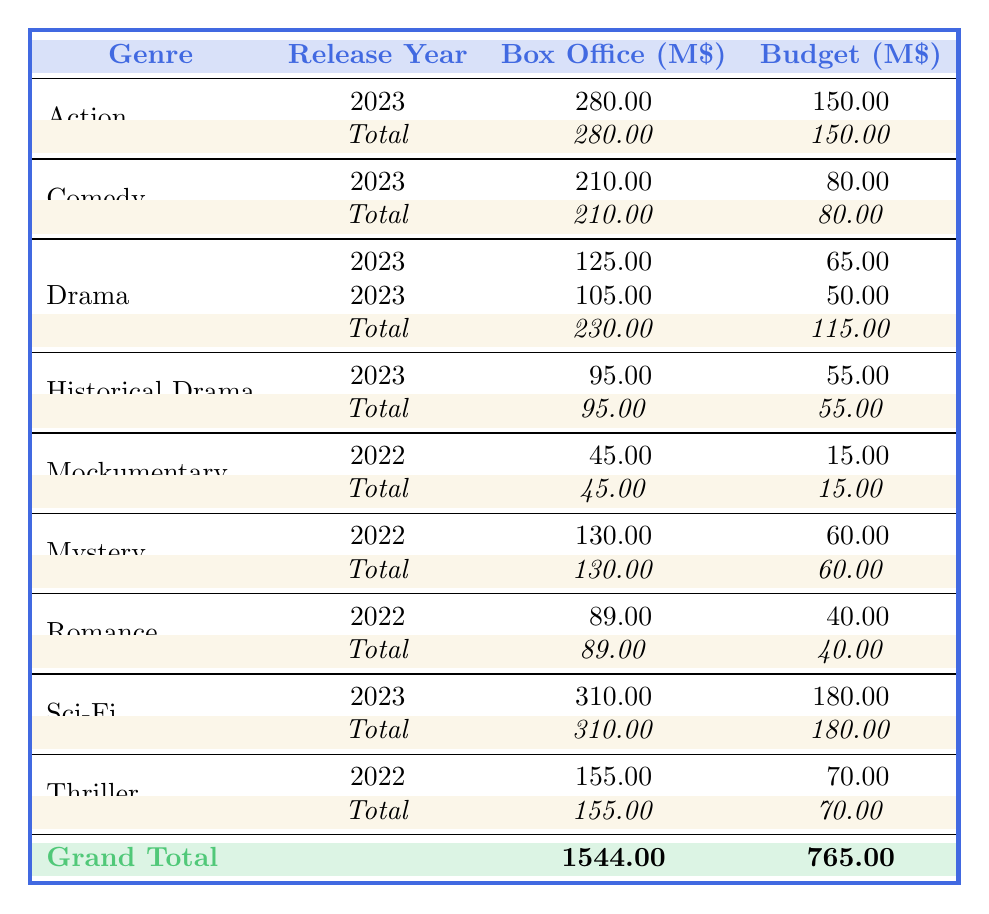What is the box office earnings of the movie "Galactic Diva"? The table lists "Galactic Diva" under the Sci-Fi genre for the year 2023 with box office earnings of 310 million dollars.
Answer: 310 million Which genre had the highest box office earnings in 2023? Looking at the table, Sci-Fi has the highest earnings at 310 million dollars compared to other genres in 2023.
Answer: Sci-Fi What is the total box office earnings for the Drama genre? The Drama genre includes two entries: "The Eccentric's Gambit" earning 125 million and "Chateau Marmont Confidential" earning 105 million. Thus, the total is 125 + 105 = 230 million.
Answer: 230 million Did the movie "Paparazzi Panic" have a higher production budget than "Midnight in Cannes"? The production budget for "Paparazzi Panic" is 80 million while "Midnight in Cannes" has a budget of 40 million. Therefore, "Paparazzi Panic" indeed has a higher budget.
Answer: Yes What is the average box office earnings for movies released in 2022? The table shows box office earnings for three movies released in 2022: "Midnight in Cannes" (89 million), "The Method Actor's Revenge" (155 million), and "The Last Take" (130 million). Summing these gives 89 + 155 + 130 = 374 million. Dividing this sum by 3 movies gives an average of 374 / 3 = 124.67 million.
Answer: 124.67 million Which genre had the least box office earnings in 2022? In the table, the genres with earnings in 2022 are Thriller (155 million), Romance (89 million), Mystery (130 million), and Mockumentary (45 million). The Mockumentary genre has the least earnings of 45 million.
Answer: Mockumentary What are the total production budgets for all movies released in 2023? The production budgets for 2023 movies are: "The Eccentric's Gambit" (65 million), "Galactic Diva" (180 million), "Paparazzi Panic" (80 million), "Red Carpet Rampage" (150 million), and "Oscar Bait" (55 million). Adding these gives 65 + 180 + 80 + 150 + 55 = 530 million.
Answer: 530 million Is the total box office earnings for Action movies greater than for Comedy movies? The total earnings for Action in 2023 is 280 million and for Comedy is 210 million. Since 280 million is greater than 210 million, the statement is true.
Answer: Yes What is the difference between the highest and lowest box office earnings across all genres? The highest box office earnings are 310 million from the Sci-Fi genre, while the lowest is 45 million from Mockumentary. The difference is 310 - 45 = 265 million.
Answer: 265 million 